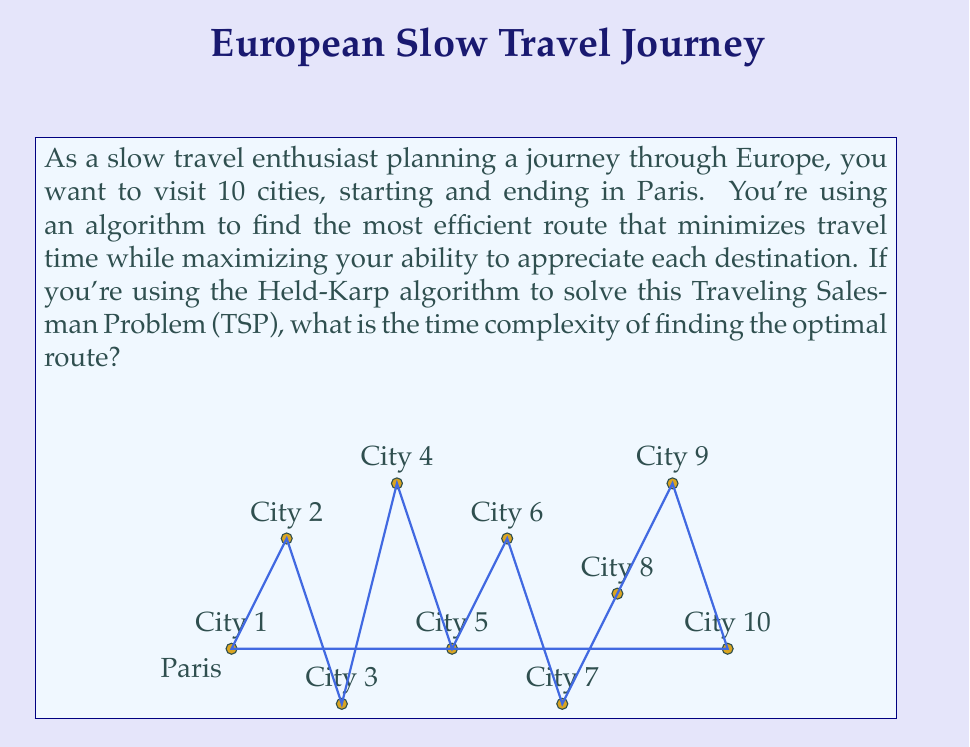Can you answer this question? To solve this problem, let's break it down step-by-step:

1) The Held-Karp algorithm is a dynamic programming solution for the Traveling Salesman Problem (TSP).

2) For n cities, the algorithm considers all possible subsets of cities and all possible last cities for each subset.

3) The number of subsets of n cities is $2^n$.

4) For each subset, we consider at most n possible last cities.

5) The algorithm fills a table with $2^n * n$ entries.

6) For each entry, we perform a maximization over at most n-1 values.

7) Therefore, the total number of operations is proportional to $2^n * n * (n-1)$.

8) In Big O notation, we can simplify this to $O(2^n * n^2)$.

9) In our specific case, we have 10 cities, so n = 10.

10) However, the time complexity is expressed in terms of n, not the specific value of 10.

The Held-Karp algorithm, while more efficient than the naive approach of checking all permutations (which would be $O(n!)$), is still exponential in the number of cities. This exponential growth means that as the number of cities increases, the time to find the optimal route grows very quickly, making it impractical for large numbers of cities.
Answer: $O(2^n * n^2)$ 